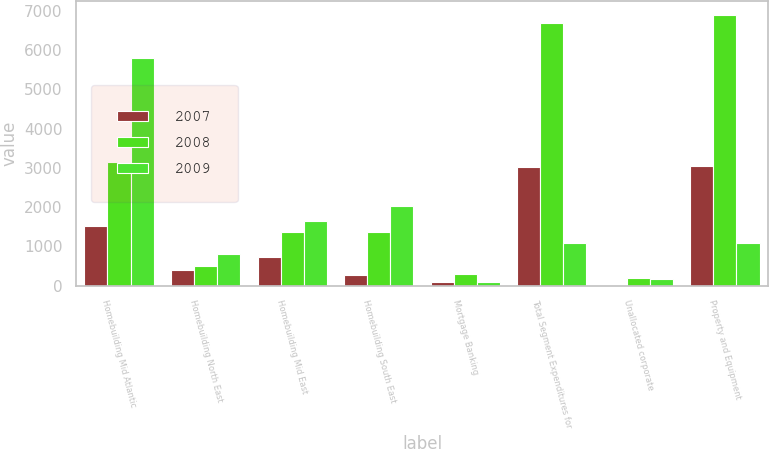Convert chart. <chart><loc_0><loc_0><loc_500><loc_500><stacked_bar_chart><ecel><fcel>Homebuilding Mid Atlantic<fcel>Homebuilding North East<fcel>Homebuilding Mid East<fcel>Homebuilding South East<fcel>Mortgage Banking<fcel>Total Segment Expenditures for<fcel>Unallocated corporate<fcel>Property and Equipment<nl><fcel>2007<fcel>1511<fcel>414<fcel>741<fcel>269<fcel>87<fcel>3022<fcel>22<fcel>3044<nl><fcel>2008<fcel>3142<fcel>508<fcel>1372<fcel>1369<fcel>305<fcel>6696<fcel>203<fcel>6899<nl><fcel>2009<fcel>5785<fcel>799<fcel>1637<fcel>2043<fcel>96<fcel>1084<fcel>185<fcel>1084<nl></chart> 